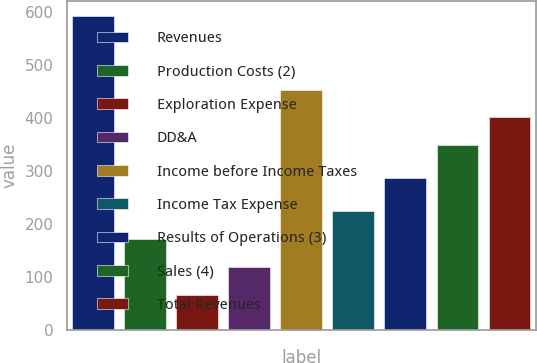Convert chart. <chart><loc_0><loc_0><loc_500><loc_500><bar_chart><fcel>Revenues<fcel>Production Costs (2)<fcel>Exploration Expense<fcel>DD&A<fcel>Income before Income Taxes<fcel>Income Tax Expense<fcel>Results of Operations (3)<fcel>Sales (4)<fcel>Total Revenues<nl><fcel>592<fcel>172<fcel>67<fcel>119.5<fcel>454<fcel>224.5<fcel>288<fcel>349<fcel>401.5<nl></chart> 